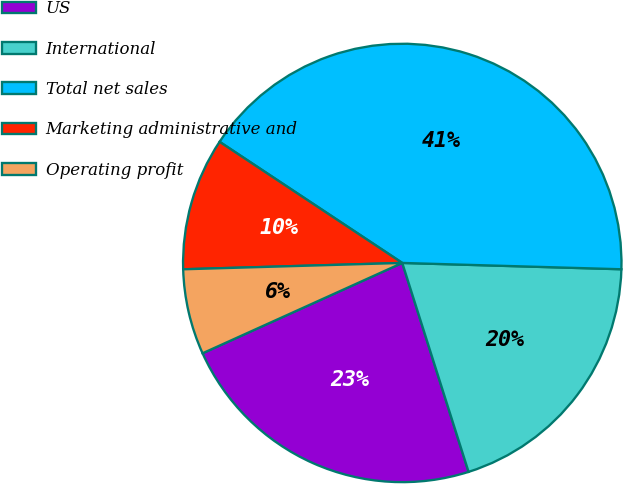<chart> <loc_0><loc_0><loc_500><loc_500><pie_chart><fcel>US<fcel>International<fcel>Total net sales<fcel>Marketing administrative and<fcel>Operating profit<nl><fcel>23.13%<fcel>19.65%<fcel>41.14%<fcel>9.78%<fcel>6.3%<nl></chart> 